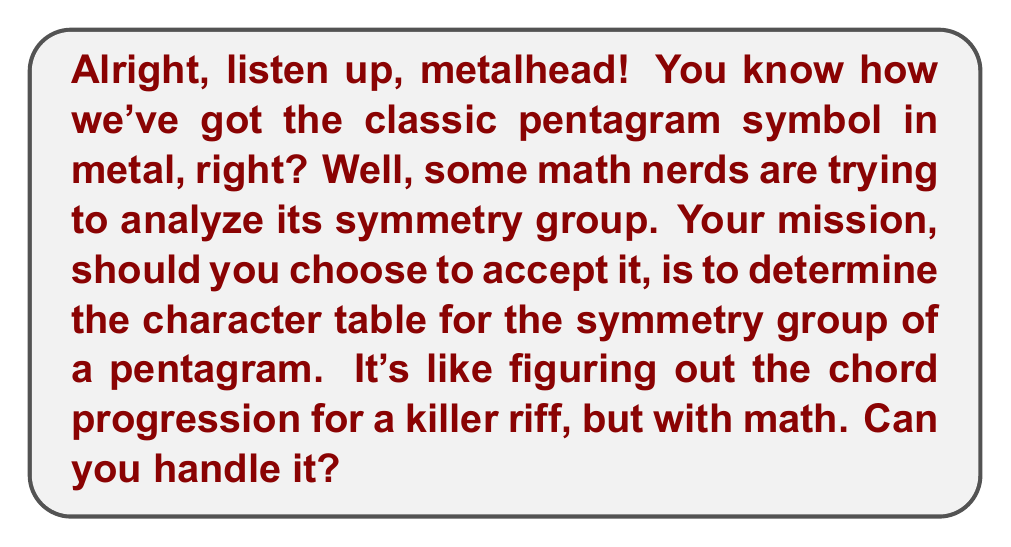Teach me how to tackle this problem. Let's break this down like we're dissecting a classic metal track:

1) First, identify the symmetry group of a pentagram. It's the dihedral group $D_5$, which has order 10.

2) The conjugacy classes of $D_5$ are:
   - $\{e\}$ (identity)
   - $\{r, r^4\}$ (rotations by 72° and 288°)
   - $\{r^2, r^3\}$ (rotations by 144° and 216°)
   - $\{s, sr, sr^2, sr^3, sr^4\}$ (reflections)

3) The number of irreducible representations equals the number of conjugacy classes, so we have 4 irreps.

4) We know two 1-dimensional representations:
   - The trivial representation: $\chi_1(g) = 1$ for all $g$
   - The sign representation: $\chi_2(g) = 1$ for rotations, $-1$ for reflections

5) The remaining two irreps must be 2-dimensional to satisfy $1^2 + 1^2 + 2^2 + 2^2 = 10$ (order of the group)

6) For the 2-dimensional irreps, we use the formula:
   $$\chi(r^k) = 2\cos(2\pi k/5)$$
   $$\chi(sr^k) = 0$$

7) This gives us $\chi_3$ and $\chi_4$, where:
   $\chi_3(r) = 2\cos(2\pi/5)$, $\chi_3(r^2) = 2\cos(4\pi/5)$
   $\chi_4(r) = 2\cos(4\pi/5)$, $\chi_4(r^2) = 2\cos(8\pi/5) = 2\cos(2\pi/5)$

8) Putting it all together in a table:

$$
\begin{array}{c|cccc}
D_5 & \{e\} & \{r,r^4\} & \{r^2,r^3\} & \{s,sr,sr^2,sr^3,sr^4\} \\
\hline
\chi_1 & 1 & 1 & 1 & 1 \\
\chi_2 & 1 & 1 & 1 & -1 \\
\chi_3 & 2 & 2\cos(2\pi/5) & 2\cos(4\pi/5) & 0 \\
\chi_4 & 2 & 2\cos(4\pi/5) & 2\cos(2\pi/5) & 0
\end{array}
$$

And there you have it, as heavy as a double bass drum and as precise as a shredding guitar solo!
Answer: $$
\begin{array}{c|cccc}
D_5 & \{e\} & \{r,r^4\} & \{r^2,r^3\} & \{s,sr,sr^2,sr^3,sr^4\} \\
\hline
\chi_1 & 1 & 1 & 1 & 1 \\
\chi_2 & 1 & 1 & 1 & -1 \\
\chi_3 & 2 & 2\cos(2\pi/5) & 2\cos(4\pi/5) & 0 \\
\chi_4 & 2 & 2\cos(4\pi/5) & 2\cos(2\pi/5) & 0
\end{array}
$$ 